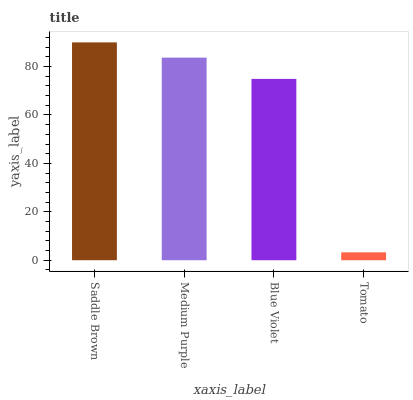Is Medium Purple the minimum?
Answer yes or no. No. Is Medium Purple the maximum?
Answer yes or no. No. Is Saddle Brown greater than Medium Purple?
Answer yes or no. Yes. Is Medium Purple less than Saddle Brown?
Answer yes or no. Yes. Is Medium Purple greater than Saddle Brown?
Answer yes or no. No. Is Saddle Brown less than Medium Purple?
Answer yes or no. No. Is Medium Purple the high median?
Answer yes or no. Yes. Is Blue Violet the low median?
Answer yes or no. Yes. Is Saddle Brown the high median?
Answer yes or no. No. Is Tomato the low median?
Answer yes or no. No. 